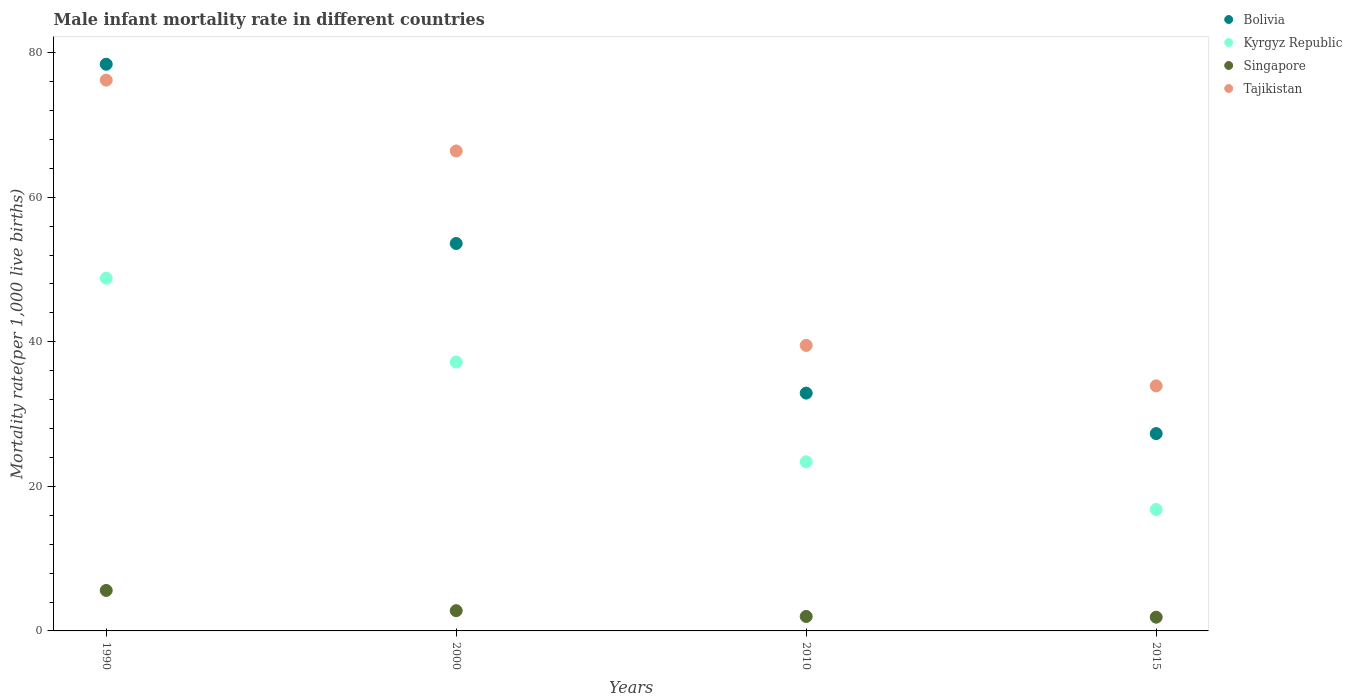Is the number of dotlines equal to the number of legend labels?
Provide a short and direct response. Yes. What is the male infant mortality rate in Tajikistan in 1990?
Give a very brief answer. 76.2. Across all years, what is the maximum male infant mortality rate in Tajikistan?
Offer a terse response. 76.2. Across all years, what is the minimum male infant mortality rate in Bolivia?
Your answer should be compact. 27.3. In which year was the male infant mortality rate in Bolivia minimum?
Ensure brevity in your answer.  2015. What is the total male infant mortality rate in Tajikistan in the graph?
Keep it short and to the point. 216. What is the difference between the male infant mortality rate in Bolivia in 2000 and that in 2015?
Your response must be concise. 26.3. What is the difference between the male infant mortality rate in Singapore in 2015 and the male infant mortality rate in Tajikistan in 2000?
Your answer should be very brief. -64.5. What is the average male infant mortality rate in Singapore per year?
Provide a succinct answer. 3.07. What is the ratio of the male infant mortality rate in Tajikistan in 1990 to that in 2010?
Offer a terse response. 1.93. Is the male infant mortality rate in Bolivia in 1990 less than that in 2015?
Your answer should be very brief. No. What is the difference between the highest and the second highest male infant mortality rate in Kyrgyz Republic?
Provide a succinct answer. 11.6. What is the difference between the highest and the lowest male infant mortality rate in Bolivia?
Ensure brevity in your answer.  51.1. In how many years, is the male infant mortality rate in Kyrgyz Republic greater than the average male infant mortality rate in Kyrgyz Republic taken over all years?
Your answer should be compact. 2. Is it the case that in every year, the sum of the male infant mortality rate in Tajikistan and male infant mortality rate in Kyrgyz Republic  is greater than the male infant mortality rate in Singapore?
Provide a short and direct response. Yes. Does the male infant mortality rate in Singapore monotonically increase over the years?
Your answer should be compact. No. What is the difference between two consecutive major ticks on the Y-axis?
Keep it short and to the point. 20. Does the graph contain any zero values?
Your answer should be compact. No. Does the graph contain grids?
Your answer should be very brief. No. How many legend labels are there?
Your response must be concise. 4. What is the title of the graph?
Make the answer very short. Male infant mortality rate in different countries. What is the label or title of the X-axis?
Ensure brevity in your answer.  Years. What is the label or title of the Y-axis?
Offer a terse response. Mortality rate(per 1,0 live births). What is the Mortality rate(per 1,000 live births) of Bolivia in 1990?
Ensure brevity in your answer.  78.4. What is the Mortality rate(per 1,000 live births) of Kyrgyz Republic in 1990?
Provide a short and direct response. 48.8. What is the Mortality rate(per 1,000 live births) of Singapore in 1990?
Offer a terse response. 5.6. What is the Mortality rate(per 1,000 live births) in Tajikistan in 1990?
Provide a short and direct response. 76.2. What is the Mortality rate(per 1,000 live births) of Bolivia in 2000?
Your answer should be very brief. 53.6. What is the Mortality rate(per 1,000 live births) of Kyrgyz Republic in 2000?
Keep it short and to the point. 37.2. What is the Mortality rate(per 1,000 live births) in Tajikistan in 2000?
Your answer should be compact. 66.4. What is the Mortality rate(per 1,000 live births) of Bolivia in 2010?
Give a very brief answer. 32.9. What is the Mortality rate(per 1,000 live births) in Kyrgyz Republic in 2010?
Offer a very short reply. 23.4. What is the Mortality rate(per 1,000 live births) of Singapore in 2010?
Offer a very short reply. 2. What is the Mortality rate(per 1,000 live births) in Tajikistan in 2010?
Offer a terse response. 39.5. What is the Mortality rate(per 1,000 live births) in Bolivia in 2015?
Give a very brief answer. 27.3. What is the Mortality rate(per 1,000 live births) in Singapore in 2015?
Offer a terse response. 1.9. What is the Mortality rate(per 1,000 live births) of Tajikistan in 2015?
Offer a very short reply. 33.9. Across all years, what is the maximum Mortality rate(per 1,000 live births) of Bolivia?
Offer a terse response. 78.4. Across all years, what is the maximum Mortality rate(per 1,000 live births) in Kyrgyz Republic?
Your answer should be compact. 48.8. Across all years, what is the maximum Mortality rate(per 1,000 live births) in Tajikistan?
Your answer should be compact. 76.2. Across all years, what is the minimum Mortality rate(per 1,000 live births) of Bolivia?
Provide a succinct answer. 27.3. Across all years, what is the minimum Mortality rate(per 1,000 live births) of Singapore?
Provide a short and direct response. 1.9. Across all years, what is the minimum Mortality rate(per 1,000 live births) in Tajikistan?
Offer a terse response. 33.9. What is the total Mortality rate(per 1,000 live births) in Bolivia in the graph?
Keep it short and to the point. 192.2. What is the total Mortality rate(per 1,000 live births) of Kyrgyz Republic in the graph?
Offer a very short reply. 126.2. What is the total Mortality rate(per 1,000 live births) of Tajikistan in the graph?
Your answer should be compact. 216. What is the difference between the Mortality rate(per 1,000 live births) of Bolivia in 1990 and that in 2000?
Provide a short and direct response. 24.8. What is the difference between the Mortality rate(per 1,000 live births) of Kyrgyz Republic in 1990 and that in 2000?
Offer a terse response. 11.6. What is the difference between the Mortality rate(per 1,000 live births) in Singapore in 1990 and that in 2000?
Ensure brevity in your answer.  2.8. What is the difference between the Mortality rate(per 1,000 live births) of Tajikistan in 1990 and that in 2000?
Your answer should be compact. 9.8. What is the difference between the Mortality rate(per 1,000 live births) in Bolivia in 1990 and that in 2010?
Your answer should be compact. 45.5. What is the difference between the Mortality rate(per 1,000 live births) of Kyrgyz Republic in 1990 and that in 2010?
Offer a very short reply. 25.4. What is the difference between the Mortality rate(per 1,000 live births) in Tajikistan in 1990 and that in 2010?
Provide a short and direct response. 36.7. What is the difference between the Mortality rate(per 1,000 live births) of Bolivia in 1990 and that in 2015?
Your answer should be very brief. 51.1. What is the difference between the Mortality rate(per 1,000 live births) in Singapore in 1990 and that in 2015?
Your response must be concise. 3.7. What is the difference between the Mortality rate(per 1,000 live births) in Tajikistan in 1990 and that in 2015?
Provide a short and direct response. 42.3. What is the difference between the Mortality rate(per 1,000 live births) of Bolivia in 2000 and that in 2010?
Offer a terse response. 20.7. What is the difference between the Mortality rate(per 1,000 live births) in Tajikistan in 2000 and that in 2010?
Provide a short and direct response. 26.9. What is the difference between the Mortality rate(per 1,000 live births) in Bolivia in 2000 and that in 2015?
Your response must be concise. 26.3. What is the difference between the Mortality rate(per 1,000 live births) in Kyrgyz Republic in 2000 and that in 2015?
Your response must be concise. 20.4. What is the difference between the Mortality rate(per 1,000 live births) in Tajikistan in 2000 and that in 2015?
Provide a short and direct response. 32.5. What is the difference between the Mortality rate(per 1,000 live births) in Bolivia in 2010 and that in 2015?
Keep it short and to the point. 5.6. What is the difference between the Mortality rate(per 1,000 live births) of Kyrgyz Republic in 2010 and that in 2015?
Give a very brief answer. 6.6. What is the difference between the Mortality rate(per 1,000 live births) of Singapore in 2010 and that in 2015?
Keep it short and to the point. 0.1. What is the difference between the Mortality rate(per 1,000 live births) of Bolivia in 1990 and the Mortality rate(per 1,000 live births) of Kyrgyz Republic in 2000?
Provide a succinct answer. 41.2. What is the difference between the Mortality rate(per 1,000 live births) in Bolivia in 1990 and the Mortality rate(per 1,000 live births) in Singapore in 2000?
Give a very brief answer. 75.6. What is the difference between the Mortality rate(per 1,000 live births) in Kyrgyz Republic in 1990 and the Mortality rate(per 1,000 live births) in Tajikistan in 2000?
Offer a very short reply. -17.6. What is the difference between the Mortality rate(per 1,000 live births) of Singapore in 1990 and the Mortality rate(per 1,000 live births) of Tajikistan in 2000?
Provide a succinct answer. -60.8. What is the difference between the Mortality rate(per 1,000 live births) of Bolivia in 1990 and the Mortality rate(per 1,000 live births) of Kyrgyz Republic in 2010?
Provide a succinct answer. 55. What is the difference between the Mortality rate(per 1,000 live births) of Bolivia in 1990 and the Mortality rate(per 1,000 live births) of Singapore in 2010?
Offer a very short reply. 76.4. What is the difference between the Mortality rate(per 1,000 live births) of Bolivia in 1990 and the Mortality rate(per 1,000 live births) of Tajikistan in 2010?
Make the answer very short. 38.9. What is the difference between the Mortality rate(per 1,000 live births) in Kyrgyz Republic in 1990 and the Mortality rate(per 1,000 live births) in Singapore in 2010?
Your response must be concise. 46.8. What is the difference between the Mortality rate(per 1,000 live births) in Singapore in 1990 and the Mortality rate(per 1,000 live births) in Tajikistan in 2010?
Keep it short and to the point. -33.9. What is the difference between the Mortality rate(per 1,000 live births) of Bolivia in 1990 and the Mortality rate(per 1,000 live births) of Kyrgyz Republic in 2015?
Your answer should be compact. 61.6. What is the difference between the Mortality rate(per 1,000 live births) in Bolivia in 1990 and the Mortality rate(per 1,000 live births) in Singapore in 2015?
Your answer should be very brief. 76.5. What is the difference between the Mortality rate(per 1,000 live births) in Bolivia in 1990 and the Mortality rate(per 1,000 live births) in Tajikistan in 2015?
Give a very brief answer. 44.5. What is the difference between the Mortality rate(per 1,000 live births) of Kyrgyz Republic in 1990 and the Mortality rate(per 1,000 live births) of Singapore in 2015?
Provide a succinct answer. 46.9. What is the difference between the Mortality rate(per 1,000 live births) in Singapore in 1990 and the Mortality rate(per 1,000 live births) in Tajikistan in 2015?
Make the answer very short. -28.3. What is the difference between the Mortality rate(per 1,000 live births) in Bolivia in 2000 and the Mortality rate(per 1,000 live births) in Kyrgyz Republic in 2010?
Provide a short and direct response. 30.2. What is the difference between the Mortality rate(per 1,000 live births) of Bolivia in 2000 and the Mortality rate(per 1,000 live births) of Singapore in 2010?
Your response must be concise. 51.6. What is the difference between the Mortality rate(per 1,000 live births) in Kyrgyz Republic in 2000 and the Mortality rate(per 1,000 live births) in Singapore in 2010?
Offer a very short reply. 35.2. What is the difference between the Mortality rate(per 1,000 live births) of Kyrgyz Republic in 2000 and the Mortality rate(per 1,000 live births) of Tajikistan in 2010?
Your answer should be compact. -2.3. What is the difference between the Mortality rate(per 1,000 live births) of Singapore in 2000 and the Mortality rate(per 1,000 live births) of Tajikistan in 2010?
Keep it short and to the point. -36.7. What is the difference between the Mortality rate(per 1,000 live births) in Bolivia in 2000 and the Mortality rate(per 1,000 live births) in Kyrgyz Republic in 2015?
Provide a short and direct response. 36.8. What is the difference between the Mortality rate(per 1,000 live births) in Bolivia in 2000 and the Mortality rate(per 1,000 live births) in Singapore in 2015?
Make the answer very short. 51.7. What is the difference between the Mortality rate(per 1,000 live births) in Bolivia in 2000 and the Mortality rate(per 1,000 live births) in Tajikistan in 2015?
Provide a short and direct response. 19.7. What is the difference between the Mortality rate(per 1,000 live births) in Kyrgyz Republic in 2000 and the Mortality rate(per 1,000 live births) in Singapore in 2015?
Your answer should be very brief. 35.3. What is the difference between the Mortality rate(per 1,000 live births) in Kyrgyz Republic in 2000 and the Mortality rate(per 1,000 live births) in Tajikistan in 2015?
Offer a terse response. 3.3. What is the difference between the Mortality rate(per 1,000 live births) in Singapore in 2000 and the Mortality rate(per 1,000 live births) in Tajikistan in 2015?
Provide a short and direct response. -31.1. What is the difference between the Mortality rate(per 1,000 live births) in Bolivia in 2010 and the Mortality rate(per 1,000 live births) in Tajikistan in 2015?
Keep it short and to the point. -1. What is the difference between the Mortality rate(per 1,000 live births) in Kyrgyz Republic in 2010 and the Mortality rate(per 1,000 live births) in Singapore in 2015?
Offer a very short reply. 21.5. What is the difference between the Mortality rate(per 1,000 live births) of Singapore in 2010 and the Mortality rate(per 1,000 live births) of Tajikistan in 2015?
Make the answer very short. -31.9. What is the average Mortality rate(per 1,000 live births) of Bolivia per year?
Offer a terse response. 48.05. What is the average Mortality rate(per 1,000 live births) in Kyrgyz Republic per year?
Ensure brevity in your answer.  31.55. What is the average Mortality rate(per 1,000 live births) of Singapore per year?
Your answer should be very brief. 3.08. In the year 1990, what is the difference between the Mortality rate(per 1,000 live births) in Bolivia and Mortality rate(per 1,000 live births) in Kyrgyz Republic?
Offer a very short reply. 29.6. In the year 1990, what is the difference between the Mortality rate(per 1,000 live births) of Bolivia and Mortality rate(per 1,000 live births) of Singapore?
Offer a very short reply. 72.8. In the year 1990, what is the difference between the Mortality rate(per 1,000 live births) in Bolivia and Mortality rate(per 1,000 live births) in Tajikistan?
Your answer should be compact. 2.2. In the year 1990, what is the difference between the Mortality rate(per 1,000 live births) of Kyrgyz Republic and Mortality rate(per 1,000 live births) of Singapore?
Keep it short and to the point. 43.2. In the year 1990, what is the difference between the Mortality rate(per 1,000 live births) of Kyrgyz Republic and Mortality rate(per 1,000 live births) of Tajikistan?
Your answer should be compact. -27.4. In the year 1990, what is the difference between the Mortality rate(per 1,000 live births) in Singapore and Mortality rate(per 1,000 live births) in Tajikistan?
Offer a terse response. -70.6. In the year 2000, what is the difference between the Mortality rate(per 1,000 live births) in Bolivia and Mortality rate(per 1,000 live births) in Singapore?
Provide a short and direct response. 50.8. In the year 2000, what is the difference between the Mortality rate(per 1,000 live births) of Kyrgyz Republic and Mortality rate(per 1,000 live births) of Singapore?
Your response must be concise. 34.4. In the year 2000, what is the difference between the Mortality rate(per 1,000 live births) of Kyrgyz Republic and Mortality rate(per 1,000 live births) of Tajikistan?
Provide a short and direct response. -29.2. In the year 2000, what is the difference between the Mortality rate(per 1,000 live births) of Singapore and Mortality rate(per 1,000 live births) of Tajikistan?
Offer a very short reply. -63.6. In the year 2010, what is the difference between the Mortality rate(per 1,000 live births) of Bolivia and Mortality rate(per 1,000 live births) of Singapore?
Your response must be concise. 30.9. In the year 2010, what is the difference between the Mortality rate(per 1,000 live births) in Bolivia and Mortality rate(per 1,000 live births) in Tajikistan?
Ensure brevity in your answer.  -6.6. In the year 2010, what is the difference between the Mortality rate(per 1,000 live births) in Kyrgyz Republic and Mortality rate(per 1,000 live births) in Singapore?
Provide a short and direct response. 21.4. In the year 2010, what is the difference between the Mortality rate(per 1,000 live births) of Kyrgyz Republic and Mortality rate(per 1,000 live births) of Tajikistan?
Your answer should be very brief. -16.1. In the year 2010, what is the difference between the Mortality rate(per 1,000 live births) of Singapore and Mortality rate(per 1,000 live births) of Tajikistan?
Offer a terse response. -37.5. In the year 2015, what is the difference between the Mortality rate(per 1,000 live births) in Bolivia and Mortality rate(per 1,000 live births) in Kyrgyz Republic?
Provide a short and direct response. 10.5. In the year 2015, what is the difference between the Mortality rate(per 1,000 live births) in Bolivia and Mortality rate(per 1,000 live births) in Singapore?
Offer a very short reply. 25.4. In the year 2015, what is the difference between the Mortality rate(per 1,000 live births) in Kyrgyz Republic and Mortality rate(per 1,000 live births) in Singapore?
Your answer should be compact. 14.9. In the year 2015, what is the difference between the Mortality rate(per 1,000 live births) of Kyrgyz Republic and Mortality rate(per 1,000 live births) of Tajikistan?
Offer a very short reply. -17.1. In the year 2015, what is the difference between the Mortality rate(per 1,000 live births) in Singapore and Mortality rate(per 1,000 live births) in Tajikistan?
Make the answer very short. -32. What is the ratio of the Mortality rate(per 1,000 live births) in Bolivia in 1990 to that in 2000?
Your answer should be compact. 1.46. What is the ratio of the Mortality rate(per 1,000 live births) in Kyrgyz Republic in 1990 to that in 2000?
Give a very brief answer. 1.31. What is the ratio of the Mortality rate(per 1,000 live births) in Singapore in 1990 to that in 2000?
Offer a terse response. 2. What is the ratio of the Mortality rate(per 1,000 live births) in Tajikistan in 1990 to that in 2000?
Ensure brevity in your answer.  1.15. What is the ratio of the Mortality rate(per 1,000 live births) in Bolivia in 1990 to that in 2010?
Ensure brevity in your answer.  2.38. What is the ratio of the Mortality rate(per 1,000 live births) of Kyrgyz Republic in 1990 to that in 2010?
Provide a succinct answer. 2.09. What is the ratio of the Mortality rate(per 1,000 live births) in Tajikistan in 1990 to that in 2010?
Your answer should be very brief. 1.93. What is the ratio of the Mortality rate(per 1,000 live births) of Bolivia in 1990 to that in 2015?
Provide a succinct answer. 2.87. What is the ratio of the Mortality rate(per 1,000 live births) of Kyrgyz Republic in 1990 to that in 2015?
Keep it short and to the point. 2.9. What is the ratio of the Mortality rate(per 1,000 live births) in Singapore in 1990 to that in 2015?
Provide a succinct answer. 2.95. What is the ratio of the Mortality rate(per 1,000 live births) in Tajikistan in 1990 to that in 2015?
Provide a short and direct response. 2.25. What is the ratio of the Mortality rate(per 1,000 live births) of Bolivia in 2000 to that in 2010?
Offer a terse response. 1.63. What is the ratio of the Mortality rate(per 1,000 live births) of Kyrgyz Republic in 2000 to that in 2010?
Offer a very short reply. 1.59. What is the ratio of the Mortality rate(per 1,000 live births) in Tajikistan in 2000 to that in 2010?
Provide a short and direct response. 1.68. What is the ratio of the Mortality rate(per 1,000 live births) in Bolivia in 2000 to that in 2015?
Ensure brevity in your answer.  1.96. What is the ratio of the Mortality rate(per 1,000 live births) in Kyrgyz Republic in 2000 to that in 2015?
Ensure brevity in your answer.  2.21. What is the ratio of the Mortality rate(per 1,000 live births) in Singapore in 2000 to that in 2015?
Provide a short and direct response. 1.47. What is the ratio of the Mortality rate(per 1,000 live births) of Tajikistan in 2000 to that in 2015?
Offer a terse response. 1.96. What is the ratio of the Mortality rate(per 1,000 live births) in Bolivia in 2010 to that in 2015?
Offer a terse response. 1.21. What is the ratio of the Mortality rate(per 1,000 live births) in Kyrgyz Republic in 2010 to that in 2015?
Offer a very short reply. 1.39. What is the ratio of the Mortality rate(per 1,000 live births) of Singapore in 2010 to that in 2015?
Your response must be concise. 1.05. What is the ratio of the Mortality rate(per 1,000 live births) in Tajikistan in 2010 to that in 2015?
Give a very brief answer. 1.17. What is the difference between the highest and the second highest Mortality rate(per 1,000 live births) of Bolivia?
Make the answer very short. 24.8. What is the difference between the highest and the second highest Mortality rate(per 1,000 live births) of Singapore?
Offer a very short reply. 2.8. What is the difference between the highest and the second highest Mortality rate(per 1,000 live births) of Tajikistan?
Offer a terse response. 9.8. What is the difference between the highest and the lowest Mortality rate(per 1,000 live births) in Bolivia?
Provide a short and direct response. 51.1. What is the difference between the highest and the lowest Mortality rate(per 1,000 live births) of Kyrgyz Republic?
Your answer should be compact. 32. What is the difference between the highest and the lowest Mortality rate(per 1,000 live births) of Singapore?
Keep it short and to the point. 3.7. What is the difference between the highest and the lowest Mortality rate(per 1,000 live births) in Tajikistan?
Provide a short and direct response. 42.3. 